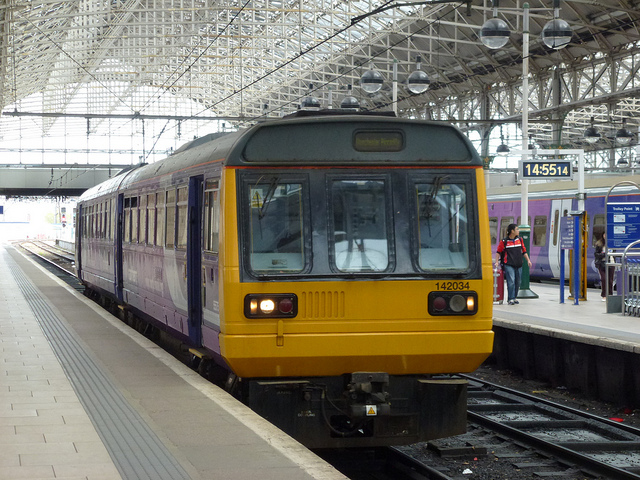Please extract the text content from this image. 14:5514 142034 